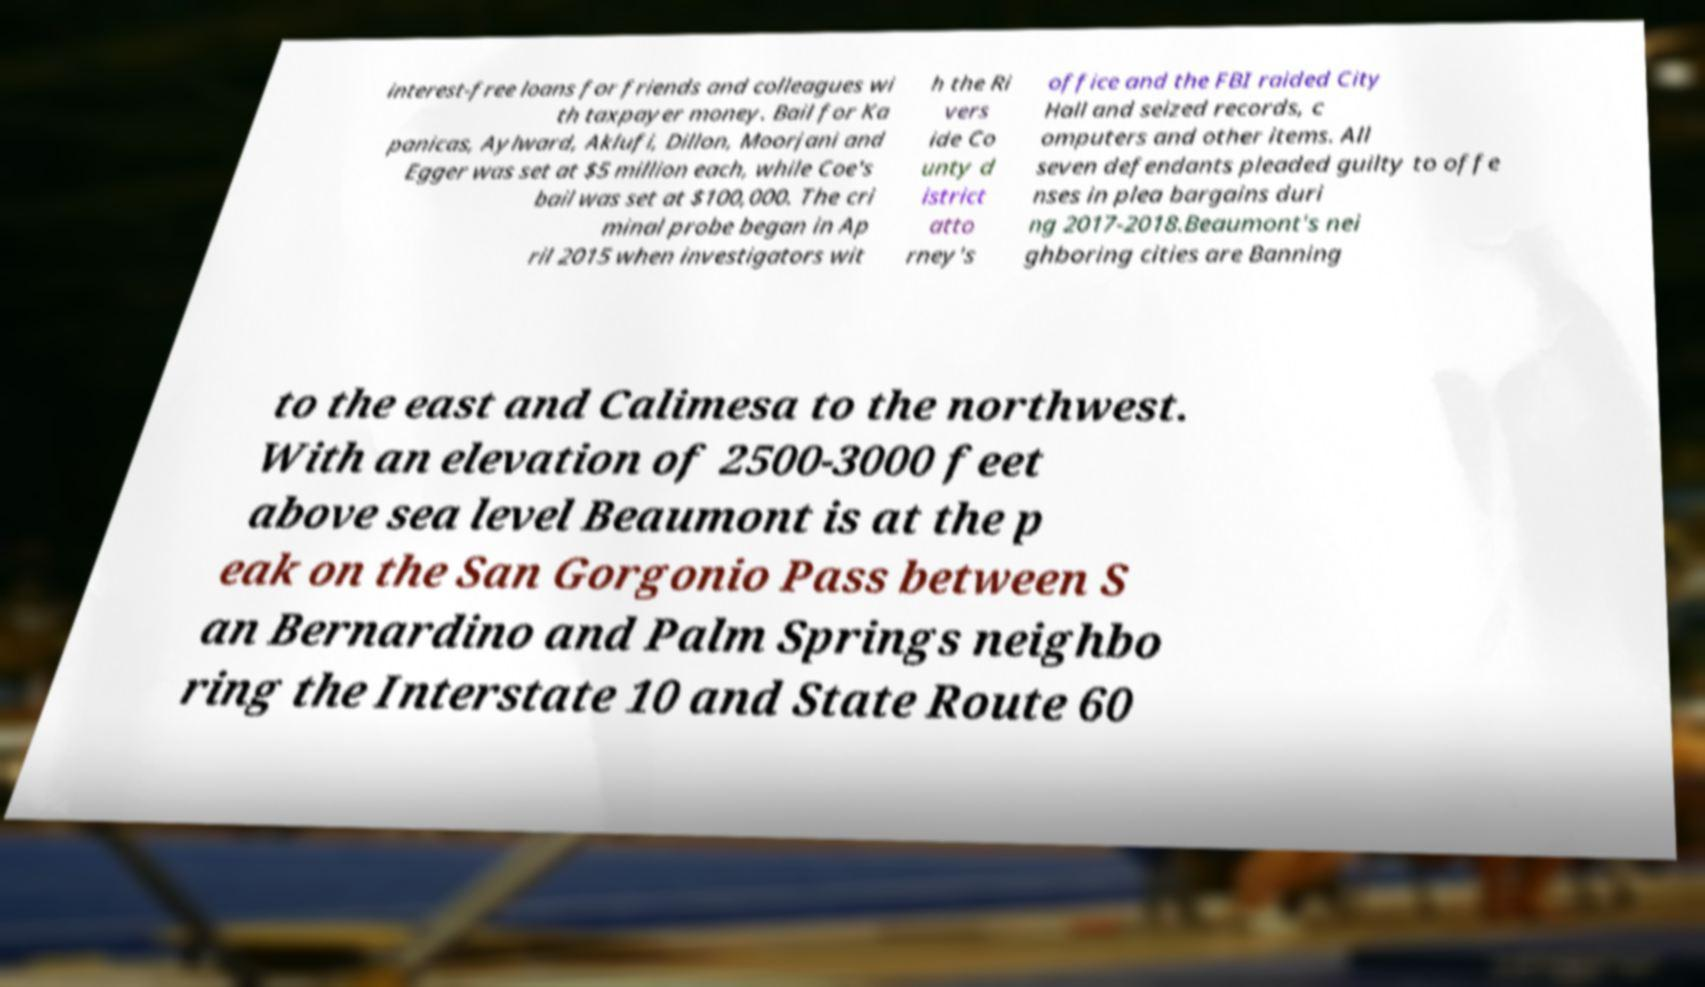I need the written content from this picture converted into text. Can you do that? interest-free loans for friends and colleagues wi th taxpayer money. Bail for Ka panicas, Aylward, Aklufi, Dillon, Moorjani and Egger was set at $5 million each, while Coe's bail was set at $100,000. The cri minal probe began in Ap ril 2015 when investigators wit h the Ri vers ide Co unty d istrict atto rney's office and the FBI raided City Hall and seized records, c omputers and other items. All seven defendants pleaded guilty to offe nses in plea bargains duri ng 2017-2018.Beaumont's nei ghboring cities are Banning to the east and Calimesa to the northwest. With an elevation of 2500-3000 feet above sea level Beaumont is at the p eak on the San Gorgonio Pass between S an Bernardino and Palm Springs neighbo ring the Interstate 10 and State Route 60 